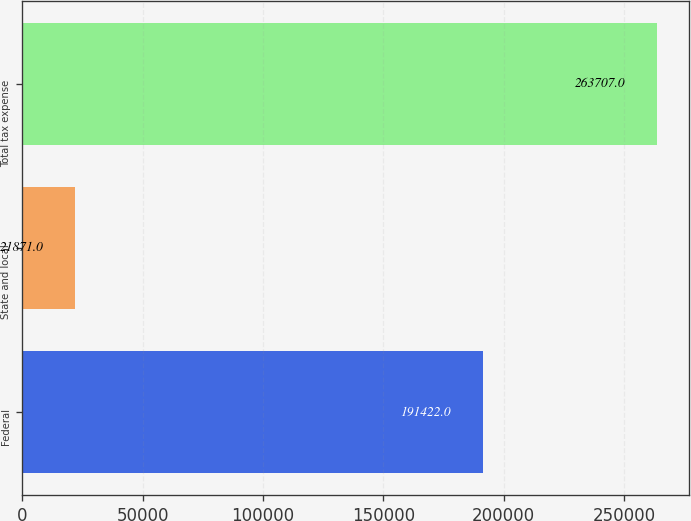<chart> <loc_0><loc_0><loc_500><loc_500><bar_chart><fcel>Federal<fcel>State and local<fcel>Total tax expense<nl><fcel>191422<fcel>21871<fcel>263707<nl></chart> 